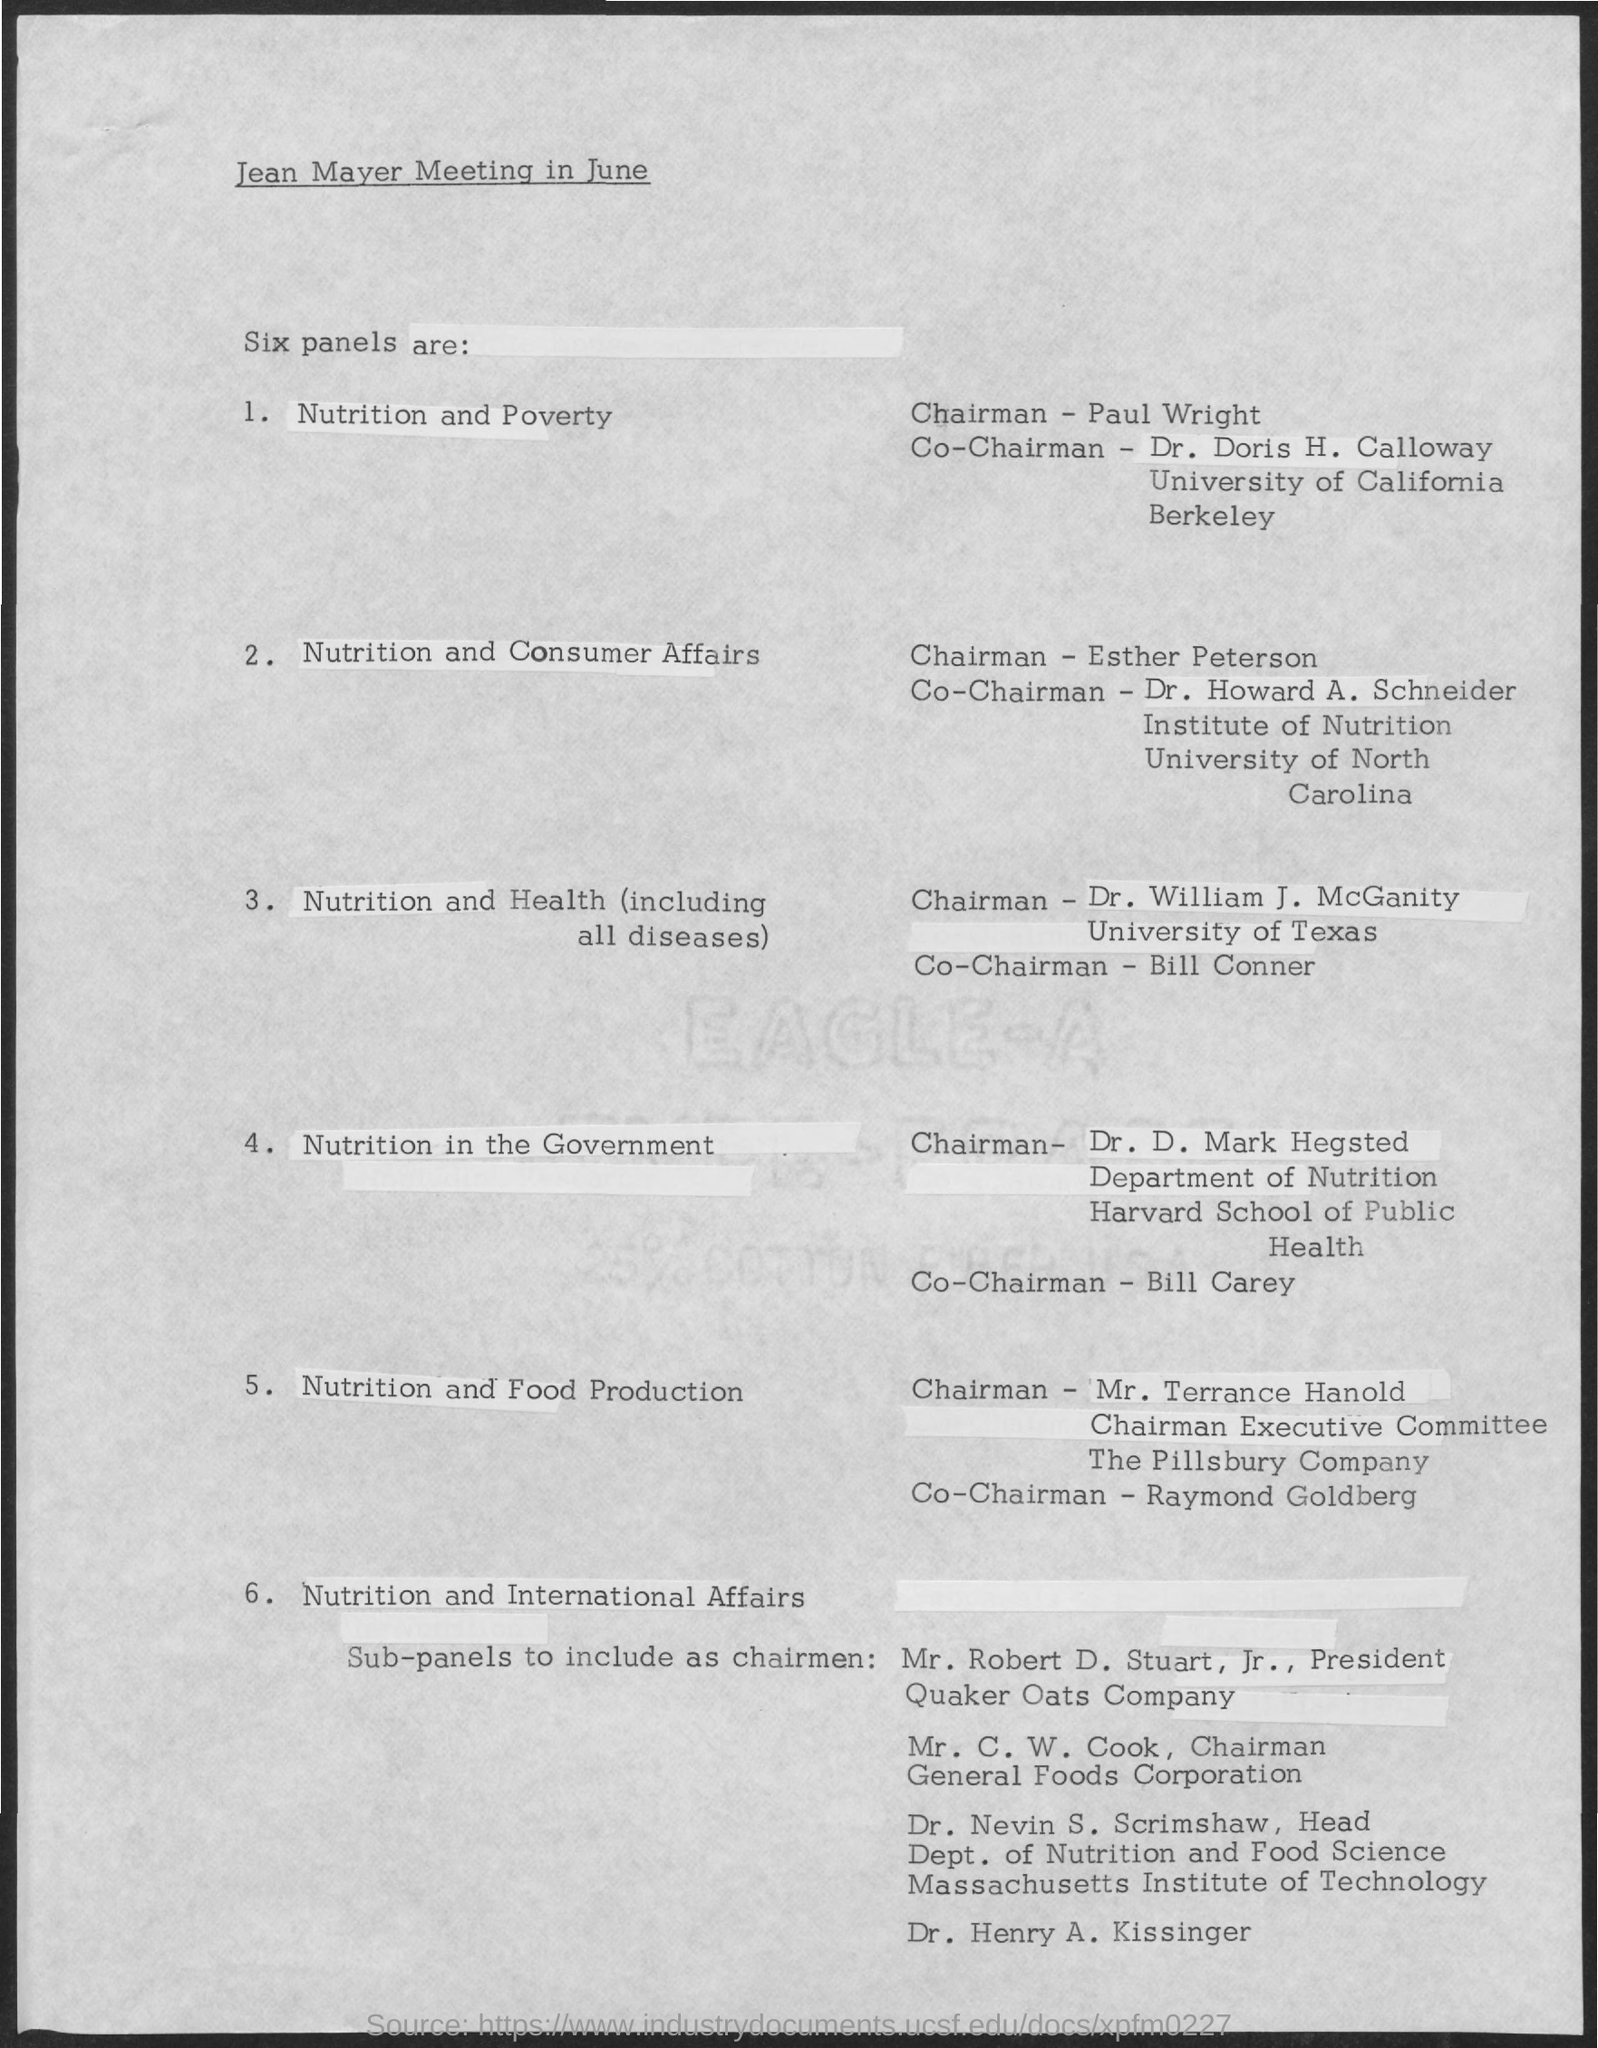Point out several critical features in this image. Paul Wright is the chairman of the nutrition and poverty panel. The co-chairman of the nutrition committee in the government is Bill Carey. The co-chairman of the nutrition and health panel is Bill Conner. Raymond Goldberg is the co-chairman of the nutrition and food production panel. The person who serves as the chairman of the Nutrition and Consumer Affairs Panel is Esther Peterson. 